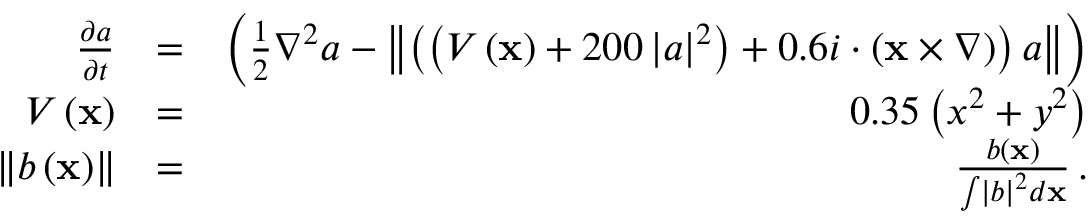<formula> <loc_0><loc_0><loc_500><loc_500>\begin{array} { r l r } { \frac { \partial a } { \partial t } } & { = } & { \left ( \frac { 1 } { 2 } \nabla ^ { 2 } a - \left \| \left ( \left ( V \left ( x \right ) + 2 0 0 \left | a \right | ^ { 2 } \right ) + 0 . 6 i \cdot \left ( x \times \nabla \right ) \right ) a \right \| \right ) } \\ { V \left ( x \right ) } & { = } & { 0 . 3 5 \left ( x ^ { 2 } + y ^ { 2 } \right ) } \\ { \left \| b \left ( x \right ) \right \| } & { = } & { \frac { b \left ( x \right ) } { \int \left | b \right | ^ { 2 } d x } \, . } \end{array}</formula> 